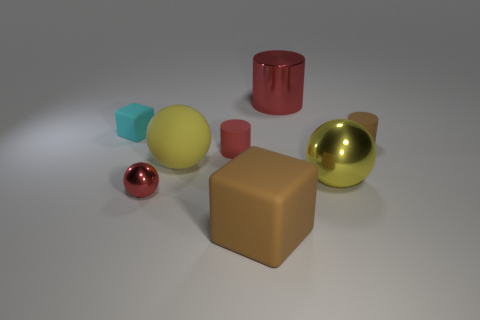There is a big metal ball; is it the same color as the large matte object behind the small red metal ball?
Make the answer very short. Yes. Does the tiny rubber cylinder in front of the small brown matte thing have the same color as the shiny cylinder?
Your answer should be compact. Yes. The small matte object that is the same shape as the large brown rubber thing is what color?
Your response must be concise. Cyan. Are there any big rubber balls of the same color as the large shiny ball?
Provide a short and direct response. Yes. Does the big matte ball have the same color as the big metallic ball?
Offer a very short reply. Yes. The large shiny object that is the same color as the small shiny object is what shape?
Keep it short and to the point. Cylinder. What number of big brown things are made of the same material as the tiny sphere?
Your answer should be compact. 0. Are there any red metal things in front of the tiny matte block?
Make the answer very short. Yes. There is a sphere that is the same size as the cyan thing; what is its color?
Make the answer very short. Red. How many things are either red cylinders that are behind the tiny brown rubber thing or blue metal things?
Make the answer very short. 1. 